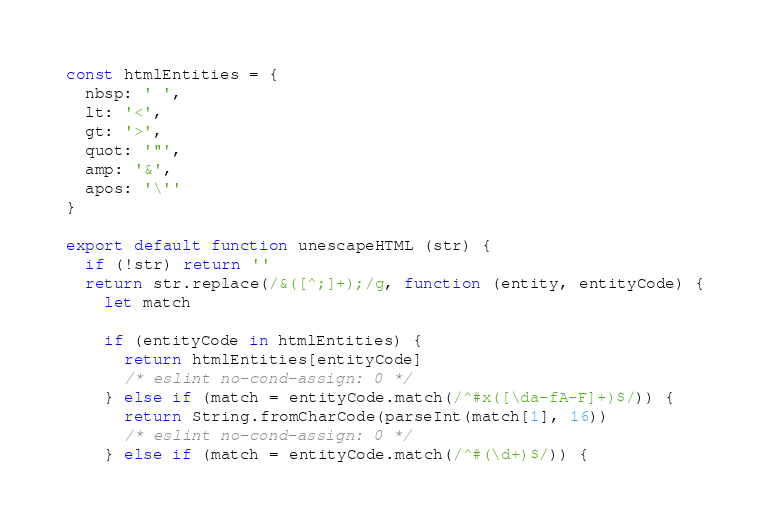<code> <loc_0><loc_0><loc_500><loc_500><_JavaScript_>const htmlEntities = {
  nbsp: ' ',
  lt: '<',
  gt: '>',
  quot: '"',
  amp: '&',
  apos: '\''
}

export default function unescapeHTML (str) {
  if (!str) return ''
  return str.replace(/&([^;]+);/g, function (entity, entityCode) {
    let match

    if (entityCode in htmlEntities) {
      return htmlEntities[entityCode]
      /* eslint no-cond-assign: 0 */
    } else if (match = entityCode.match(/^#x([\da-fA-F]+)$/)) {
      return String.fromCharCode(parseInt(match[1], 16))
      /* eslint no-cond-assign: 0 */
    } else if (match = entityCode.match(/^#(\d+)$/)) {</code> 